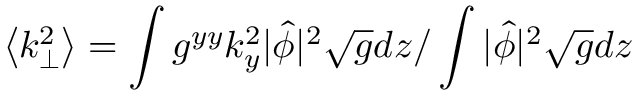<formula> <loc_0><loc_0><loc_500><loc_500>\left < k _ { \perp } ^ { 2 } \right > = \int g ^ { y y } k _ { y } ^ { 2 } | \hat { \phi } | ^ { 2 } \sqrt { g } d z / \int | \hat { \phi } | ^ { 2 } \sqrt { g } d z</formula> 